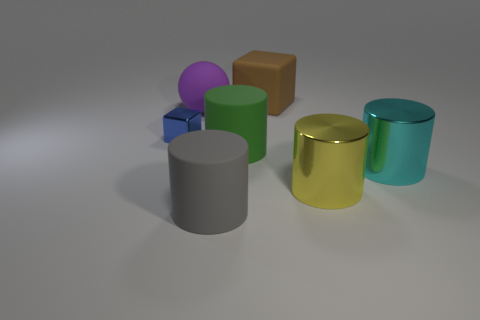There is another object that is the same shape as the big brown object; what material is it?
Your response must be concise. Metal. There is a matte object that is behind the small block and to the right of the large ball; what size is it?
Make the answer very short. Large. There is a cyan cylinder that is the same size as the rubber sphere; what is its material?
Provide a short and direct response. Metal. How many large rubber things are in front of the metal object that is on the left side of the big object behind the big purple rubber thing?
Provide a succinct answer. 2. Is the color of the matte object that is on the left side of the big gray matte object the same as the cube behind the metallic block?
Your answer should be very brief. No. There is a metallic thing that is both to the right of the big gray matte cylinder and behind the yellow metal cylinder; what color is it?
Offer a very short reply. Cyan. How many yellow metallic cylinders are the same size as the ball?
Your response must be concise. 1. What shape is the large matte object in front of the large metallic thing that is left of the large cyan metal thing?
Keep it short and to the point. Cylinder. What shape is the large cyan thing to the right of the big rubber cylinder that is on the right side of the big rubber cylinder that is on the left side of the large green rubber thing?
Make the answer very short. Cylinder. How many other metallic objects are the same shape as the large gray thing?
Your answer should be very brief. 2. 